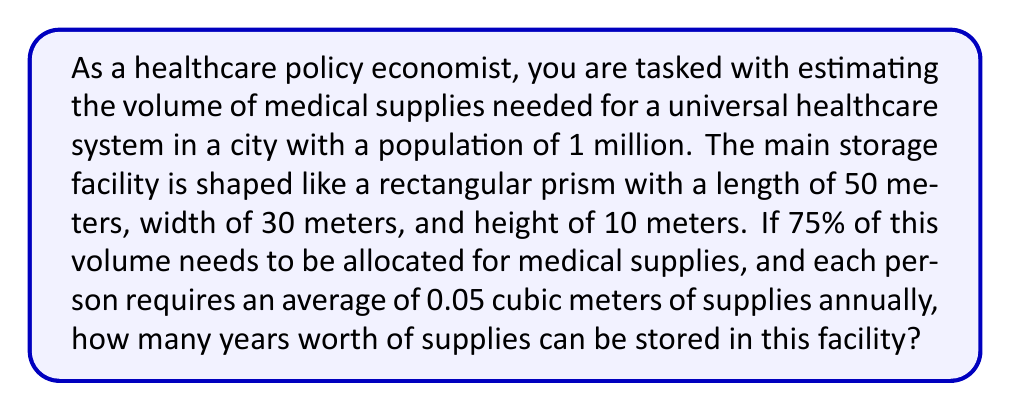Solve this math problem. To solve this problem, we need to follow these steps:

1. Calculate the total volume of the storage facility:
   $$V_{total} = l \times w \times h = 50 \text{ m} \times 30 \text{ m} \times 10 \text{ m} = 15,000 \text{ m}^3$$

2. Calculate the volume available for medical supplies (75% of total):
   $$V_{supplies} = 0.75 \times V_{total} = 0.75 \times 15,000 \text{ m}^3 = 11,250 \text{ m}^3$$

3. Calculate the annual volume of supplies needed for the entire population:
   $$V_{annual} = 0.05 \text{ m}^3 \times 1,000,000 \text{ people} = 50,000 \text{ m}^3$$

4. Calculate the number of years worth of supplies that can be stored:
   $$\text{Years of supply} = \frac{V_{supplies}}{V_{annual}} = \frac{11,250 \text{ m}^3}{50,000 \text{ m}^3/\text{year}} = 0.225 \text{ years}$$

5. Convert the result to months for a more practical representation:
   $$0.225 \text{ years} \times 12 \text{ months/year} = 2.7 \text{ months}$$
Answer: The storage facility can hold approximately 2.7 months worth of medical supplies for the given population. 